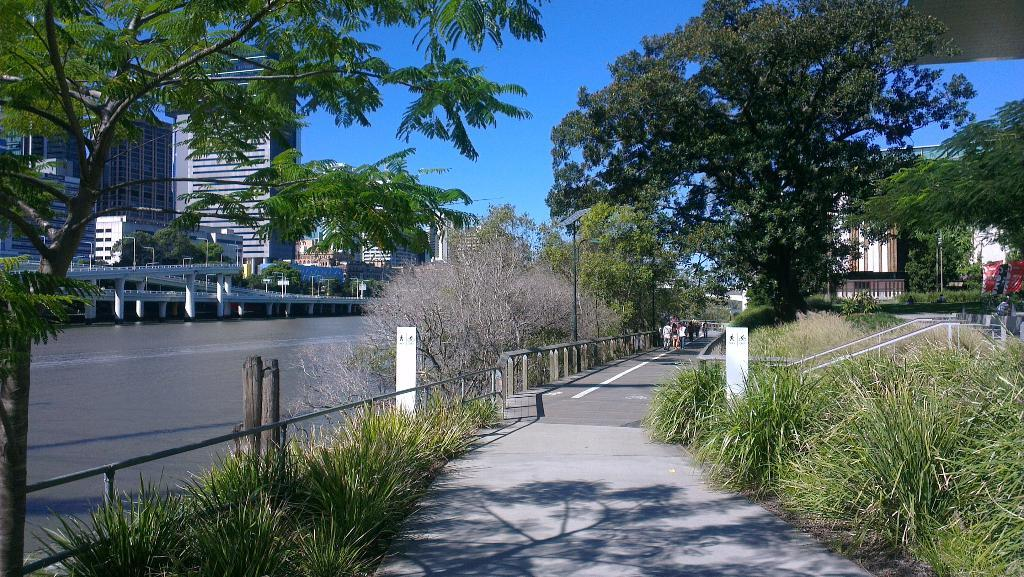How many people are in the group visible in the image? There is a group of people standing in the image, but the exact number cannot be determined from the provided facts. What type of pathway is present in the image? There is a walkway in the image. What type of vegetation is present in the image? Grass, plants, and trees are visible in the image. What type of construction materials are present in the image? Iron rods, poles, and buildings are visible in the image. What type of water feature is present in the image? There is water in the image, and a bridge is present as well. What type of illumination is present in the image? Lights are present in the image. What type of sky is visible in the image? The sky is visible in the image. Can you tell me how many dogs are holding a pen in the image? There are no dogs or pens present in the image. How many hands are visible in the image? There is no mention of hands in the provided facts, so we cannot determine how many are visible in the image. 